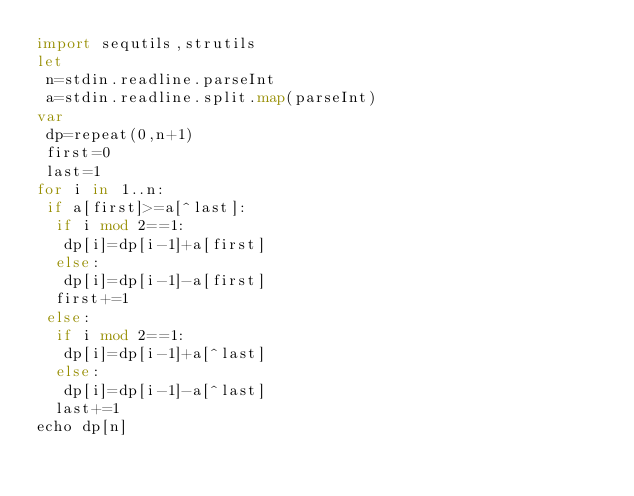<code> <loc_0><loc_0><loc_500><loc_500><_Nim_>import sequtils,strutils
let
 n=stdin.readline.parseInt
 a=stdin.readline.split.map(parseInt)
var
 dp=repeat(0,n+1)
 first=0
 last=1
for i in 1..n:
 if a[first]>=a[^last]:
  if i mod 2==1:
   dp[i]=dp[i-1]+a[first]
  else:
   dp[i]=dp[i-1]-a[first]
  first+=1
 else:
  if i mod 2==1:
   dp[i]=dp[i-1]+a[^last]
  else:
   dp[i]=dp[i-1]-a[^last]
  last+=1
echo dp[n]</code> 